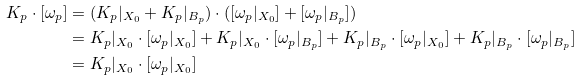Convert formula to latex. <formula><loc_0><loc_0><loc_500><loc_500>K _ { p } \cdot [ \omega _ { p } ] & = ( K _ { p } | _ { X _ { 0 } } + K _ { p } | _ { B _ { p } } ) \cdot ( [ \omega _ { p } | _ { X _ { 0 } } ] + [ \omega _ { p } | _ { B _ { p } } ] ) \\ & = K _ { p } | _ { X _ { 0 } } \cdot [ \omega _ { p } | _ { X _ { 0 } } ] + K _ { p } | _ { X _ { 0 } } \cdot [ \omega _ { p } | _ { B _ { p } } ] + K _ { p } | _ { B _ { p } } \cdot [ \omega _ { p } | _ { X _ { 0 } } ] + K _ { p } | _ { B _ { p } } \cdot [ \omega _ { p } | _ { B _ { p } } ] \\ & = K _ { p } | _ { X _ { 0 } } \cdot [ \omega _ { p } | _ { X _ { 0 } } ]</formula> 